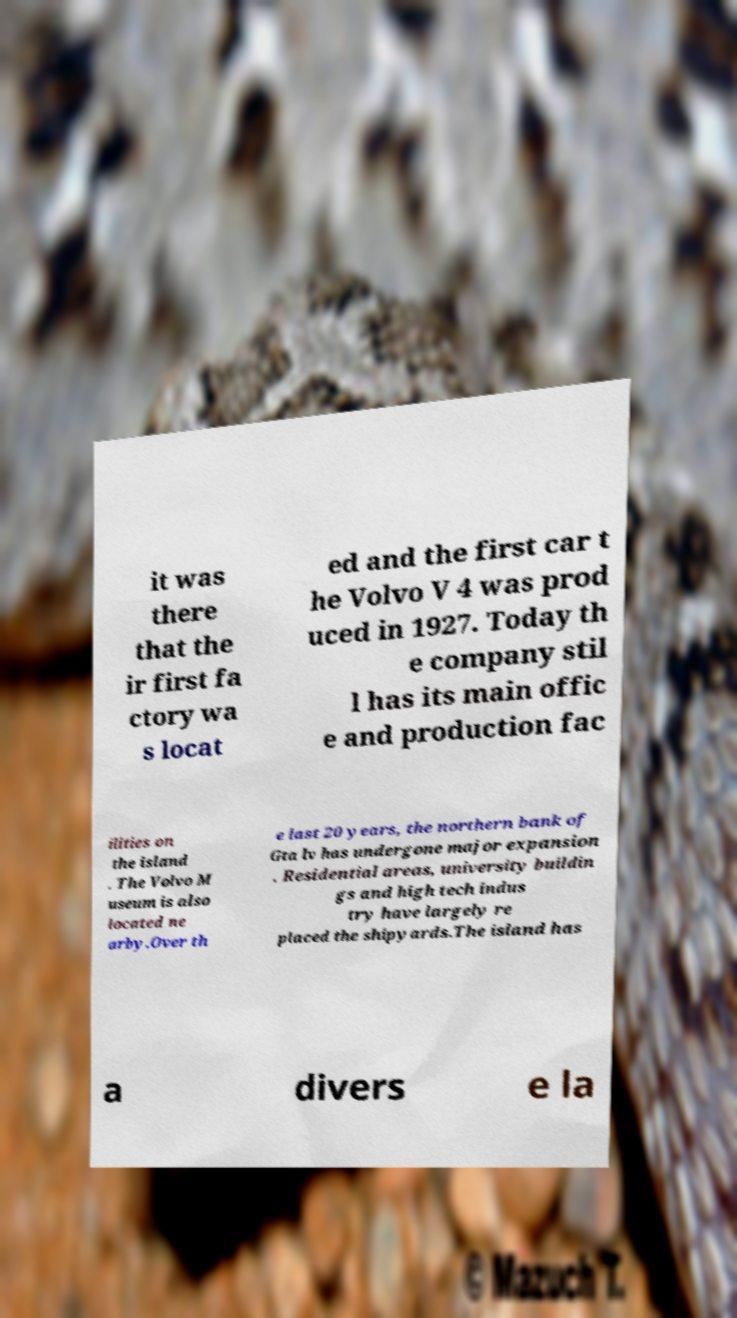Please identify and transcribe the text found in this image. it was there that the ir first fa ctory wa s locat ed and the first car t he Volvo V 4 was prod uced in 1927. Today th e company stil l has its main offic e and production fac ilities on the island . The Volvo M useum is also located ne arby.Over th e last 20 years, the northern bank of Gta lv has undergone major expansion . Residential areas, university buildin gs and high tech indus try have largely re placed the shipyards.The island has a divers e la 